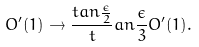<formula> <loc_0><loc_0><loc_500><loc_500>O ^ { \prime } ( 1 ) \to \frac { t a n \frac { \epsilon } { 2 } } t a n \frac { \epsilon } { 3 } O ^ { \prime } ( 1 ) .</formula> 